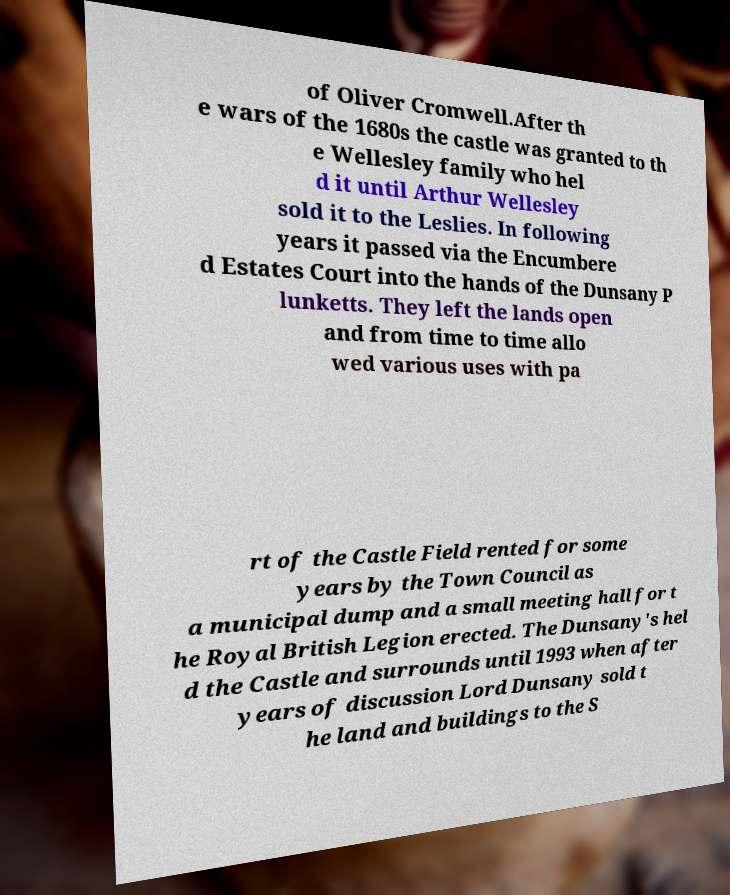Can you read and provide the text displayed in the image?This photo seems to have some interesting text. Can you extract and type it out for me? of Oliver Cromwell.After th e wars of the 1680s the castle was granted to th e Wellesley family who hel d it until Arthur Wellesley sold it to the Leslies. In following years it passed via the Encumbere d Estates Court into the hands of the Dunsany P lunketts. They left the lands open and from time to time allo wed various uses with pa rt of the Castle Field rented for some years by the Town Council as a municipal dump and a small meeting hall for t he Royal British Legion erected. The Dunsany's hel d the Castle and surrounds until 1993 when after years of discussion Lord Dunsany sold t he land and buildings to the S 